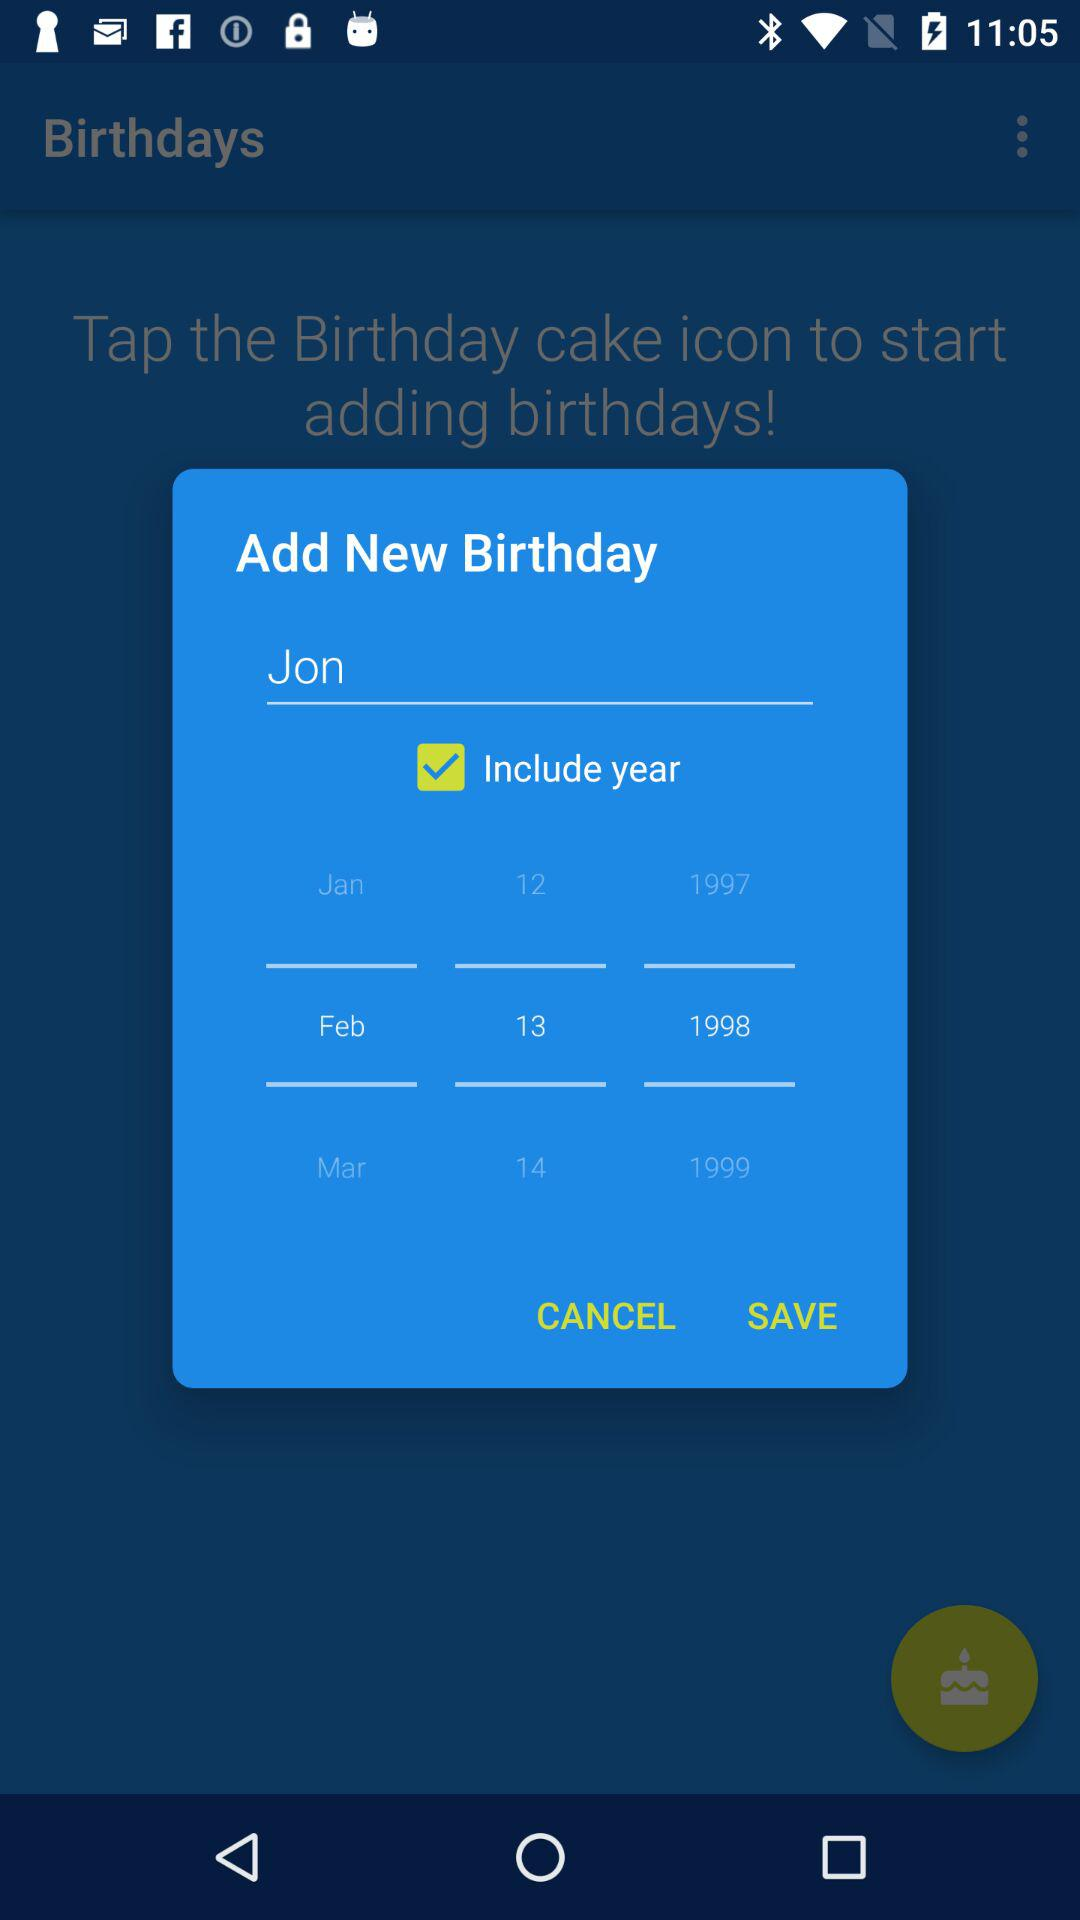Whose date of birth is selected? The person whose date of birth is selected is Jon. 